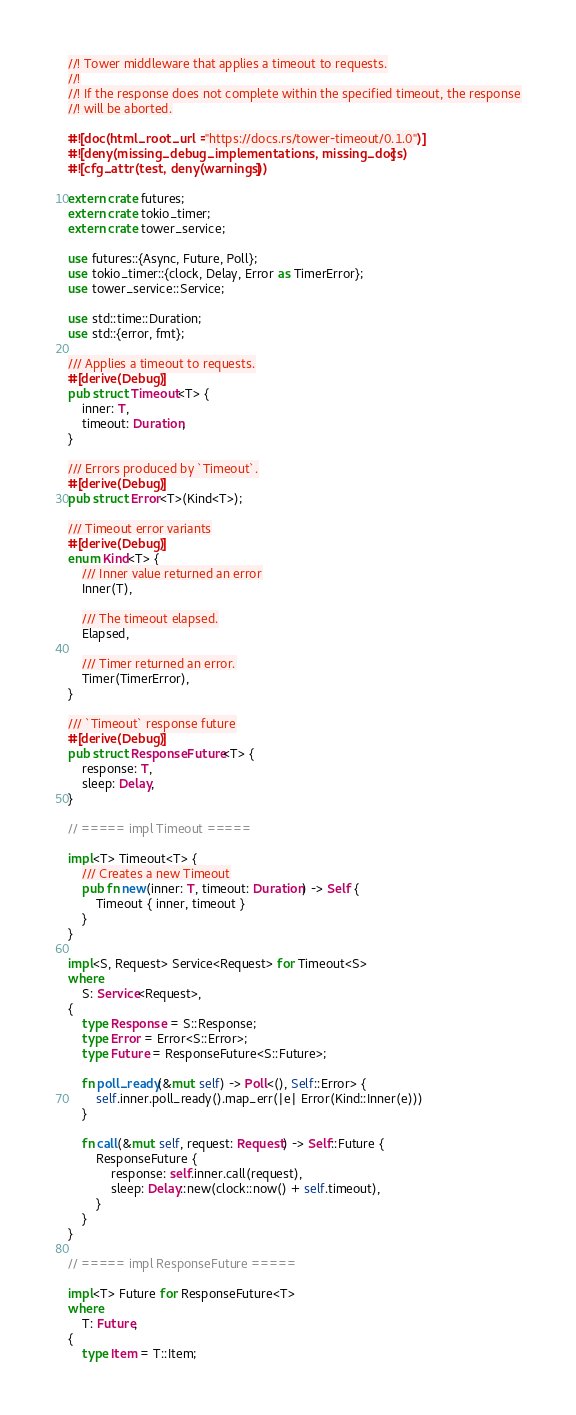<code> <loc_0><loc_0><loc_500><loc_500><_Rust_>//! Tower middleware that applies a timeout to requests.
//!
//! If the response does not complete within the specified timeout, the response
//! will be aborted.

#![doc(html_root_url = "https://docs.rs/tower-timeout/0.1.0")]
#![deny(missing_debug_implementations, missing_docs)]
#![cfg_attr(test, deny(warnings))]

extern crate futures;
extern crate tokio_timer;
extern crate tower_service;

use futures::{Async, Future, Poll};
use tokio_timer::{clock, Delay, Error as TimerError};
use tower_service::Service;

use std::time::Duration;
use std::{error, fmt};

/// Applies a timeout to requests.
#[derive(Debug)]
pub struct Timeout<T> {
    inner: T,
    timeout: Duration,
}

/// Errors produced by `Timeout`.
#[derive(Debug)]
pub struct Error<T>(Kind<T>);

/// Timeout error variants
#[derive(Debug)]
enum Kind<T> {
    /// Inner value returned an error
    Inner(T),

    /// The timeout elapsed.
    Elapsed,

    /// Timer returned an error.
    Timer(TimerError),
}

/// `Timeout` response future
#[derive(Debug)]
pub struct ResponseFuture<T> {
    response: T,
    sleep: Delay,
}

// ===== impl Timeout =====

impl<T> Timeout<T> {
    /// Creates a new Timeout
    pub fn new(inner: T, timeout: Duration) -> Self {
        Timeout { inner, timeout }
    }
}

impl<S, Request> Service<Request> for Timeout<S>
where
    S: Service<Request>,
{
    type Response = S::Response;
    type Error = Error<S::Error>;
    type Future = ResponseFuture<S::Future>;

    fn poll_ready(&mut self) -> Poll<(), Self::Error> {
        self.inner.poll_ready().map_err(|e| Error(Kind::Inner(e)))
    }

    fn call(&mut self, request: Request) -> Self::Future {
        ResponseFuture {
            response: self.inner.call(request),
            sleep: Delay::new(clock::now() + self.timeout),
        }
    }
}

// ===== impl ResponseFuture =====

impl<T> Future for ResponseFuture<T>
where
    T: Future,
{
    type Item = T::Item;</code> 